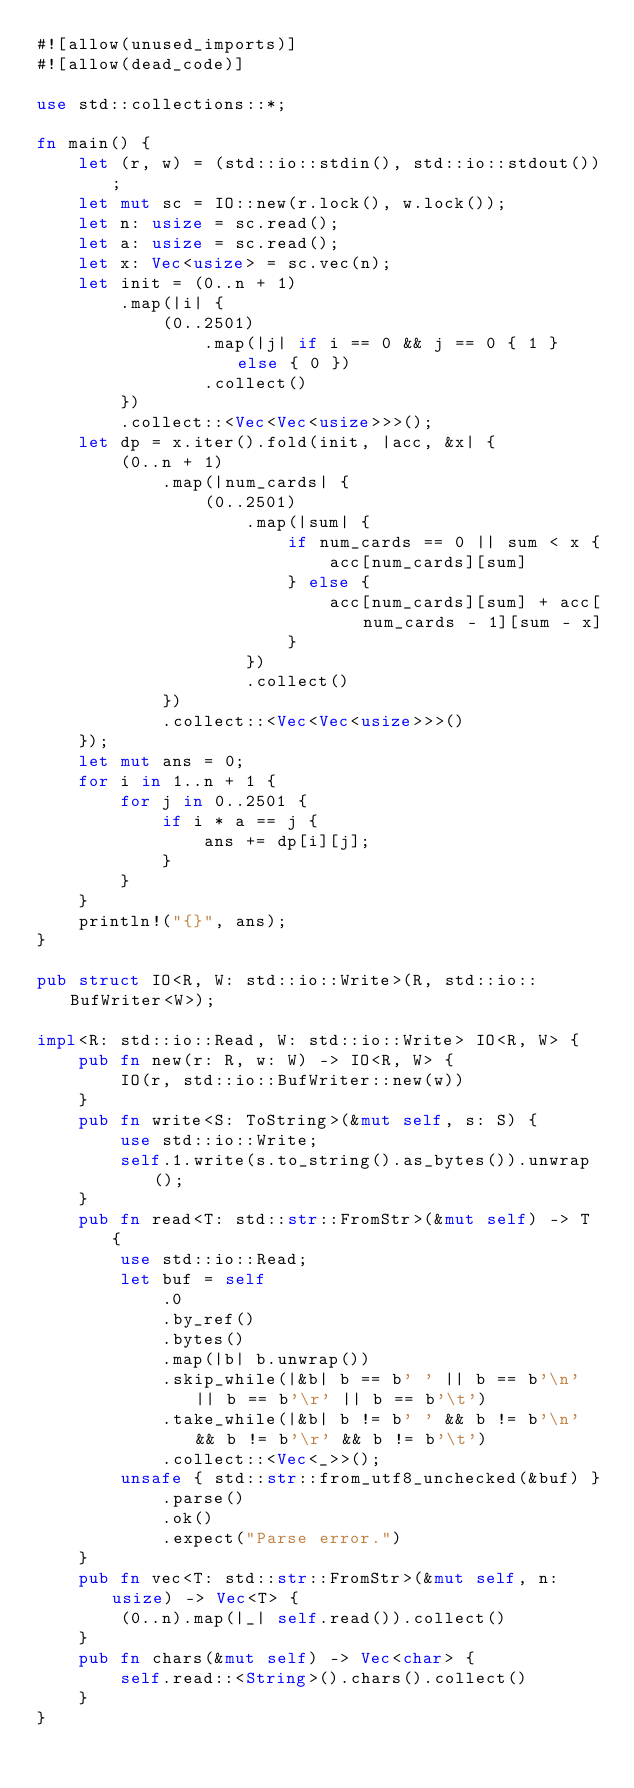Convert code to text. <code><loc_0><loc_0><loc_500><loc_500><_Rust_>#![allow(unused_imports)]
#![allow(dead_code)]

use std::collections::*;

fn main() {
    let (r, w) = (std::io::stdin(), std::io::stdout());
    let mut sc = IO::new(r.lock(), w.lock());
    let n: usize = sc.read();
    let a: usize = sc.read();
    let x: Vec<usize> = sc.vec(n);
    let init = (0..n + 1)
        .map(|i| {
            (0..2501)
                .map(|j| if i == 0 && j == 0 { 1 } else { 0 })
                .collect()
        })
        .collect::<Vec<Vec<usize>>>();
    let dp = x.iter().fold(init, |acc, &x| {
        (0..n + 1)
            .map(|num_cards| {
                (0..2501)
                    .map(|sum| {
                        if num_cards == 0 || sum < x {
                            acc[num_cards][sum]
                        } else {
                            acc[num_cards][sum] + acc[num_cards - 1][sum - x]
                        }
                    })
                    .collect()
            })
            .collect::<Vec<Vec<usize>>>()
    });
    let mut ans = 0;
    for i in 1..n + 1 {
        for j in 0..2501 {
            if i * a == j {
                ans += dp[i][j];
            }
        }
    }
    println!("{}", ans);
}

pub struct IO<R, W: std::io::Write>(R, std::io::BufWriter<W>);

impl<R: std::io::Read, W: std::io::Write> IO<R, W> {
    pub fn new(r: R, w: W) -> IO<R, W> {
        IO(r, std::io::BufWriter::new(w))
    }
    pub fn write<S: ToString>(&mut self, s: S) {
        use std::io::Write;
        self.1.write(s.to_string().as_bytes()).unwrap();
    }
    pub fn read<T: std::str::FromStr>(&mut self) -> T {
        use std::io::Read;
        let buf = self
            .0
            .by_ref()
            .bytes()
            .map(|b| b.unwrap())
            .skip_while(|&b| b == b' ' || b == b'\n' || b == b'\r' || b == b'\t')
            .take_while(|&b| b != b' ' && b != b'\n' && b != b'\r' && b != b'\t')
            .collect::<Vec<_>>();
        unsafe { std::str::from_utf8_unchecked(&buf) }
            .parse()
            .ok()
            .expect("Parse error.")
    }
    pub fn vec<T: std::str::FromStr>(&mut self, n: usize) -> Vec<T> {
        (0..n).map(|_| self.read()).collect()
    }
    pub fn chars(&mut self) -> Vec<char> {
        self.read::<String>().chars().collect()
    }
}</code> 